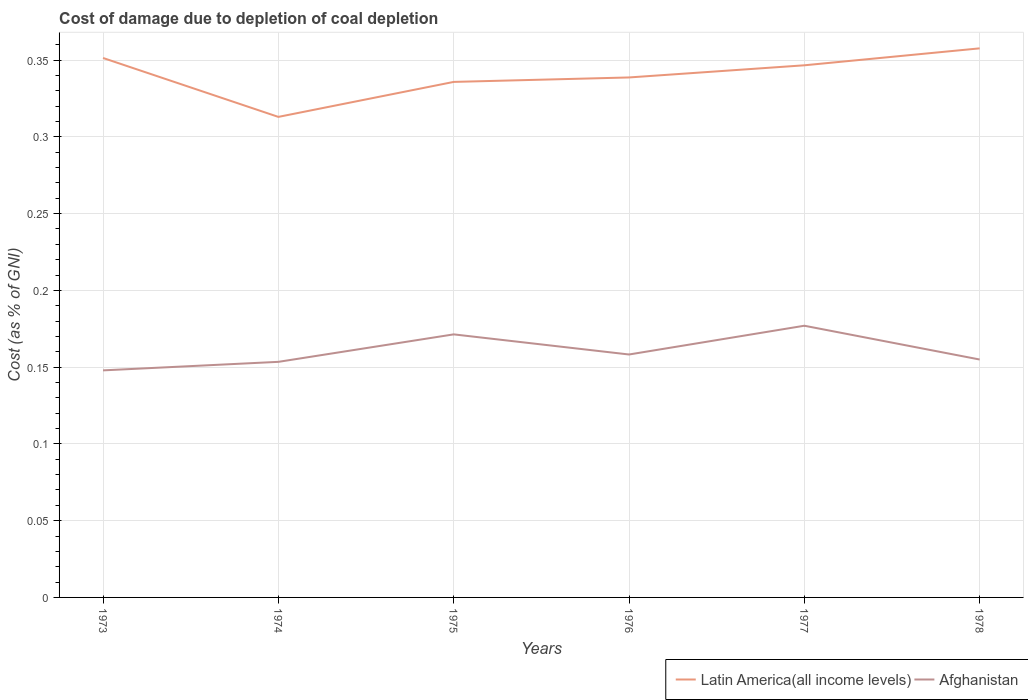Does the line corresponding to Latin America(all income levels) intersect with the line corresponding to Afghanistan?
Ensure brevity in your answer.  No. Across all years, what is the maximum cost of damage caused due to coal depletion in Latin America(all income levels)?
Make the answer very short. 0.31. What is the total cost of damage caused due to coal depletion in Latin America(all income levels) in the graph?
Your response must be concise. 0.02. What is the difference between the highest and the second highest cost of damage caused due to coal depletion in Latin America(all income levels)?
Provide a short and direct response. 0.04. What is the difference between the highest and the lowest cost of damage caused due to coal depletion in Latin America(all income levels)?
Make the answer very short. 3. Is the cost of damage caused due to coal depletion in Afghanistan strictly greater than the cost of damage caused due to coal depletion in Latin America(all income levels) over the years?
Offer a very short reply. Yes. How many years are there in the graph?
Keep it short and to the point. 6. What is the difference between two consecutive major ticks on the Y-axis?
Give a very brief answer. 0.05. Are the values on the major ticks of Y-axis written in scientific E-notation?
Provide a succinct answer. No. Does the graph contain any zero values?
Provide a short and direct response. No. Where does the legend appear in the graph?
Your answer should be compact. Bottom right. What is the title of the graph?
Offer a very short reply. Cost of damage due to depletion of coal depletion. What is the label or title of the Y-axis?
Ensure brevity in your answer.  Cost (as % of GNI). What is the Cost (as % of GNI) of Latin America(all income levels) in 1973?
Offer a terse response. 0.35. What is the Cost (as % of GNI) of Afghanistan in 1973?
Provide a succinct answer. 0.15. What is the Cost (as % of GNI) of Latin America(all income levels) in 1974?
Offer a terse response. 0.31. What is the Cost (as % of GNI) of Afghanistan in 1974?
Provide a succinct answer. 0.15. What is the Cost (as % of GNI) in Latin America(all income levels) in 1975?
Offer a terse response. 0.34. What is the Cost (as % of GNI) in Afghanistan in 1975?
Your answer should be very brief. 0.17. What is the Cost (as % of GNI) in Latin America(all income levels) in 1976?
Offer a very short reply. 0.34. What is the Cost (as % of GNI) of Afghanistan in 1976?
Make the answer very short. 0.16. What is the Cost (as % of GNI) of Latin America(all income levels) in 1977?
Your answer should be very brief. 0.35. What is the Cost (as % of GNI) of Afghanistan in 1977?
Provide a short and direct response. 0.18. What is the Cost (as % of GNI) of Latin America(all income levels) in 1978?
Your answer should be compact. 0.36. What is the Cost (as % of GNI) in Afghanistan in 1978?
Make the answer very short. 0.15. Across all years, what is the maximum Cost (as % of GNI) of Latin America(all income levels)?
Your answer should be very brief. 0.36. Across all years, what is the maximum Cost (as % of GNI) in Afghanistan?
Ensure brevity in your answer.  0.18. Across all years, what is the minimum Cost (as % of GNI) in Latin America(all income levels)?
Provide a succinct answer. 0.31. Across all years, what is the minimum Cost (as % of GNI) of Afghanistan?
Offer a terse response. 0.15. What is the total Cost (as % of GNI) in Latin America(all income levels) in the graph?
Offer a terse response. 2.04. What is the total Cost (as % of GNI) of Afghanistan in the graph?
Offer a very short reply. 0.96. What is the difference between the Cost (as % of GNI) of Latin America(all income levels) in 1973 and that in 1974?
Your answer should be very brief. 0.04. What is the difference between the Cost (as % of GNI) of Afghanistan in 1973 and that in 1974?
Your answer should be compact. -0.01. What is the difference between the Cost (as % of GNI) of Latin America(all income levels) in 1973 and that in 1975?
Your answer should be compact. 0.02. What is the difference between the Cost (as % of GNI) in Afghanistan in 1973 and that in 1975?
Your answer should be compact. -0.02. What is the difference between the Cost (as % of GNI) in Latin America(all income levels) in 1973 and that in 1976?
Give a very brief answer. 0.01. What is the difference between the Cost (as % of GNI) in Afghanistan in 1973 and that in 1976?
Ensure brevity in your answer.  -0.01. What is the difference between the Cost (as % of GNI) in Latin America(all income levels) in 1973 and that in 1977?
Your response must be concise. 0. What is the difference between the Cost (as % of GNI) of Afghanistan in 1973 and that in 1977?
Your response must be concise. -0.03. What is the difference between the Cost (as % of GNI) in Latin America(all income levels) in 1973 and that in 1978?
Offer a terse response. -0.01. What is the difference between the Cost (as % of GNI) in Afghanistan in 1973 and that in 1978?
Your response must be concise. -0.01. What is the difference between the Cost (as % of GNI) of Latin America(all income levels) in 1974 and that in 1975?
Ensure brevity in your answer.  -0.02. What is the difference between the Cost (as % of GNI) in Afghanistan in 1974 and that in 1975?
Offer a terse response. -0.02. What is the difference between the Cost (as % of GNI) of Latin America(all income levels) in 1974 and that in 1976?
Make the answer very short. -0.03. What is the difference between the Cost (as % of GNI) of Afghanistan in 1974 and that in 1976?
Keep it short and to the point. -0. What is the difference between the Cost (as % of GNI) in Latin America(all income levels) in 1974 and that in 1977?
Ensure brevity in your answer.  -0.03. What is the difference between the Cost (as % of GNI) of Afghanistan in 1974 and that in 1977?
Your answer should be compact. -0.02. What is the difference between the Cost (as % of GNI) of Latin America(all income levels) in 1974 and that in 1978?
Provide a short and direct response. -0.04. What is the difference between the Cost (as % of GNI) in Afghanistan in 1974 and that in 1978?
Your answer should be compact. -0. What is the difference between the Cost (as % of GNI) of Latin America(all income levels) in 1975 and that in 1976?
Your answer should be compact. -0. What is the difference between the Cost (as % of GNI) of Afghanistan in 1975 and that in 1976?
Offer a terse response. 0.01. What is the difference between the Cost (as % of GNI) in Latin America(all income levels) in 1975 and that in 1977?
Ensure brevity in your answer.  -0.01. What is the difference between the Cost (as % of GNI) in Afghanistan in 1975 and that in 1977?
Offer a terse response. -0.01. What is the difference between the Cost (as % of GNI) of Latin America(all income levels) in 1975 and that in 1978?
Provide a short and direct response. -0.02. What is the difference between the Cost (as % of GNI) in Afghanistan in 1975 and that in 1978?
Offer a terse response. 0.02. What is the difference between the Cost (as % of GNI) in Latin America(all income levels) in 1976 and that in 1977?
Offer a terse response. -0.01. What is the difference between the Cost (as % of GNI) in Afghanistan in 1976 and that in 1977?
Offer a very short reply. -0.02. What is the difference between the Cost (as % of GNI) in Latin America(all income levels) in 1976 and that in 1978?
Give a very brief answer. -0.02. What is the difference between the Cost (as % of GNI) of Afghanistan in 1976 and that in 1978?
Your answer should be very brief. 0. What is the difference between the Cost (as % of GNI) in Latin America(all income levels) in 1977 and that in 1978?
Offer a terse response. -0.01. What is the difference between the Cost (as % of GNI) in Afghanistan in 1977 and that in 1978?
Provide a succinct answer. 0.02. What is the difference between the Cost (as % of GNI) of Latin America(all income levels) in 1973 and the Cost (as % of GNI) of Afghanistan in 1974?
Give a very brief answer. 0.2. What is the difference between the Cost (as % of GNI) of Latin America(all income levels) in 1973 and the Cost (as % of GNI) of Afghanistan in 1975?
Provide a short and direct response. 0.18. What is the difference between the Cost (as % of GNI) of Latin America(all income levels) in 1973 and the Cost (as % of GNI) of Afghanistan in 1976?
Provide a short and direct response. 0.19. What is the difference between the Cost (as % of GNI) in Latin America(all income levels) in 1973 and the Cost (as % of GNI) in Afghanistan in 1977?
Your answer should be compact. 0.17. What is the difference between the Cost (as % of GNI) in Latin America(all income levels) in 1973 and the Cost (as % of GNI) in Afghanistan in 1978?
Provide a short and direct response. 0.2. What is the difference between the Cost (as % of GNI) of Latin America(all income levels) in 1974 and the Cost (as % of GNI) of Afghanistan in 1975?
Your answer should be very brief. 0.14. What is the difference between the Cost (as % of GNI) in Latin America(all income levels) in 1974 and the Cost (as % of GNI) in Afghanistan in 1976?
Your response must be concise. 0.15. What is the difference between the Cost (as % of GNI) in Latin America(all income levels) in 1974 and the Cost (as % of GNI) in Afghanistan in 1977?
Provide a short and direct response. 0.14. What is the difference between the Cost (as % of GNI) of Latin America(all income levels) in 1974 and the Cost (as % of GNI) of Afghanistan in 1978?
Offer a terse response. 0.16. What is the difference between the Cost (as % of GNI) in Latin America(all income levels) in 1975 and the Cost (as % of GNI) in Afghanistan in 1976?
Provide a short and direct response. 0.18. What is the difference between the Cost (as % of GNI) of Latin America(all income levels) in 1975 and the Cost (as % of GNI) of Afghanistan in 1977?
Ensure brevity in your answer.  0.16. What is the difference between the Cost (as % of GNI) of Latin America(all income levels) in 1975 and the Cost (as % of GNI) of Afghanistan in 1978?
Make the answer very short. 0.18. What is the difference between the Cost (as % of GNI) of Latin America(all income levels) in 1976 and the Cost (as % of GNI) of Afghanistan in 1977?
Give a very brief answer. 0.16. What is the difference between the Cost (as % of GNI) of Latin America(all income levels) in 1976 and the Cost (as % of GNI) of Afghanistan in 1978?
Make the answer very short. 0.18. What is the difference between the Cost (as % of GNI) in Latin America(all income levels) in 1977 and the Cost (as % of GNI) in Afghanistan in 1978?
Your answer should be very brief. 0.19. What is the average Cost (as % of GNI) in Latin America(all income levels) per year?
Provide a short and direct response. 0.34. What is the average Cost (as % of GNI) of Afghanistan per year?
Provide a succinct answer. 0.16. In the year 1973, what is the difference between the Cost (as % of GNI) of Latin America(all income levels) and Cost (as % of GNI) of Afghanistan?
Keep it short and to the point. 0.2. In the year 1974, what is the difference between the Cost (as % of GNI) of Latin America(all income levels) and Cost (as % of GNI) of Afghanistan?
Your answer should be very brief. 0.16. In the year 1975, what is the difference between the Cost (as % of GNI) of Latin America(all income levels) and Cost (as % of GNI) of Afghanistan?
Your response must be concise. 0.16. In the year 1976, what is the difference between the Cost (as % of GNI) in Latin America(all income levels) and Cost (as % of GNI) in Afghanistan?
Your answer should be very brief. 0.18. In the year 1977, what is the difference between the Cost (as % of GNI) in Latin America(all income levels) and Cost (as % of GNI) in Afghanistan?
Keep it short and to the point. 0.17. In the year 1978, what is the difference between the Cost (as % of GNI) in Latin America(all income levels) and Cost (as % of GNI) in Afghanistan?
Your answer should be very brief. 0.2. What is the ratio of the Cost (as % of GNI) in Latin America(all income levels) in 1973 to that in 1974?
Provide a short and direct response. 1.12. What is the ratio of the Cost (as % of GNI) in Afghanistan in 1973 to that in 1974?
Keep it short and to the point. 0.96. What is the ratio of the Cost (as % of GNI) of Latin America(all income levels) in 1973 to that in 1975?
Offer a terse response. 1.05. What is the ratio of the Cost (as % of GNI) in Afghanistan in 1973 to that in 1975?
Make the answer very short. 0.86. What is the ratio of the Cost (as % of GNI) in Latin America(all income levels) in 1973 to that in 1976?
Provide a short and direct response. 1.04. What is the ratio of the Cost (as % of GNI) in Afghanistan in 1973 to that in 1976?
Provide a succinct answer. 0.93. What is the ratio of the Cost (as % of GNI) of Latin America(all income levels) in 1973 to that in 1977?
Ensure brevity in your answer.  1.01. What is the ratio of the Cost (as % of GNI) of Afghanistan in 1973 to that in 1977?
Make the answer very short. 0.84. What is the ratio of the Cost (as % of GNI) in Latin America(all income levels) in 1973 to that in 1978?
Your answer should be very brief. 0.98. What is the ratio of the Cost (as % of GNI) in Afghanistan in 1973 to that in 1978?
Offer a very short reply. 0.95. What is the ratio of the Cost (as % of GNI) of Latin America(all income levels) in 1974 to that in 1975?
Ensure brevity in your answer.  0.93. What is the ratio of the Cost (as % of GNI) of Afghanistan in 1974 to that in 1975?
Make the answer very short. 0.9. What is the ratio of the Cost (as % of GNI) of Latin America(all income levels) in 1974 to that in 1976?
Offer a very short reply. 0.92. What is the ratio of the Cost (as % of GNI) of Afghanistan in 1974 to that in 1976?
Your response must be concise. 0.97. What is the ratio of the Cost (as % of GNI) in Latin America(all income levels) in 1974 to that in 1977?
Your answer should be very brief. 0.9. What is the ratio of the Cost (as % of GNI) of Afghanistan in 1974 to that in 1977?
Your answer should be compact. 0.87. What is the ratio of the Cost (as % of GNI) of Latin America(all income levels) in 1974 to that in 1978?
Give a very brief answer. 0.88. What is the ratio of the Cost (as % of GNI) in Afghanistan in 1974 to that in 1978?
Your answer should be compact. 0.99. What is the ratio of the Cost (as % of GNI) in Latin America(all income levels) in 1975 to that in 1976?
Give a very brief answer. 0.99. What is the ratio of the Cost (as % of GNI) of Afghanistan in 1975 to that in 1976?
Provide a succinct answer. 1.08. What is the ratio of the Cost (as % of GNI) in Latin America(all income levels) in 1975 to that in 1977?
Keep it short and to the point. 0.97. What is the ratio of the Cost (as % of GNI) of Afghanistan in 1975 to that in 1977?
Offer a terse response. 0.97. What is the ratio of the Cost (as % of GNI) of Latin America(all income levels) in 1975 to that in 1978?
Provide a succinct answer. 0.94. What is the ratio of the Cost (as % of GNI) of Afghanistan in 1975 to that in 1978?
Make the answer very short. 1.11. What is the ratio of the Cost (as % of GNI) in Latin America(all income levels) in 1976 to that in 1977?
Your response must be concise. 0.98. What is the ratio of the Cost (as % of GNI) of Afghanistan in 1976 to that in 1977?
Offer a very short reply. 0.89. What is the ratio of the Cost (as % of GNI) of Latin America(all income levels) in 1976 to that in 1978?
Ensure brevity in your answer.  0.95. What is the ratio of the Cost (as % of GNI) in Afghanistan in 1976 to that in 1978?
Your answer should be very brief. 1.02. What is the ratio of the Cost (as % of GNI) in Latin America(all income levels) in 1977 to that in 1978?
Offer a very short reply. 0.97. What is the ratio of the Cost (as % of GNI) in Afghanistan in 1977 to that in 1978?
Offer a terse response. 1.14. What is the difference between the highest and the second highest Cost (as % of GNI) in Latin America(all income levels)?
Your answer should be compact. 0.01. What is the difference between the highest and the second highest Cost (as % of GNI) in Afghanistan?
Your answer should be very brief. 0.01. What is the difference between the highest and the lowest Cost (as % of GNI) of Latin America(all income levels)?
Make the answer very short. 0.04. What is the difference between the highest and the lowest Cost (as % of GNI) in Afghanistan?
Your response must be concise. 0.03. 